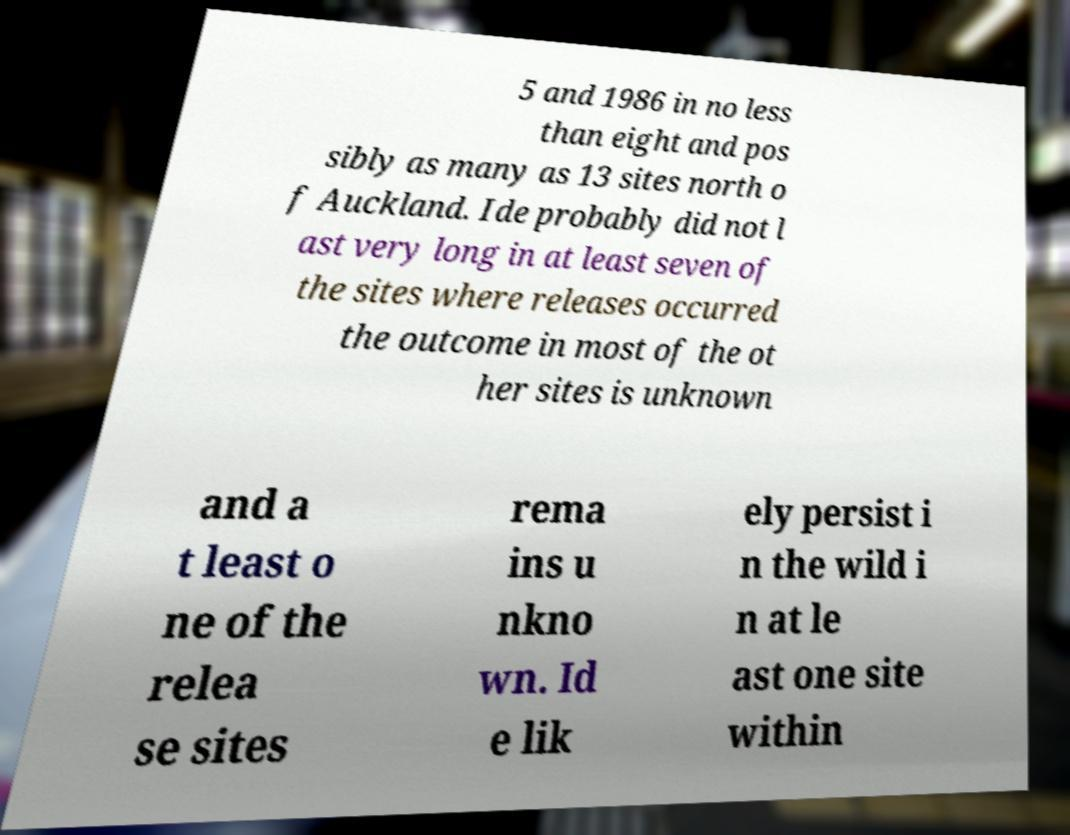I need the written content from this picture converted into text. Can you do that? 5 and 1986 in no less than eight and pos sibly as many as 13 sites north o f Auckland. Ide probably did not l ast very long in at least seven of the sites where releases occurred the outcome in most of the ot her sites is unknown and a t least o ne of the relea se sites rema ins u nkno wn. Id e lik ely persist i n the wild i n at le ast one site within 